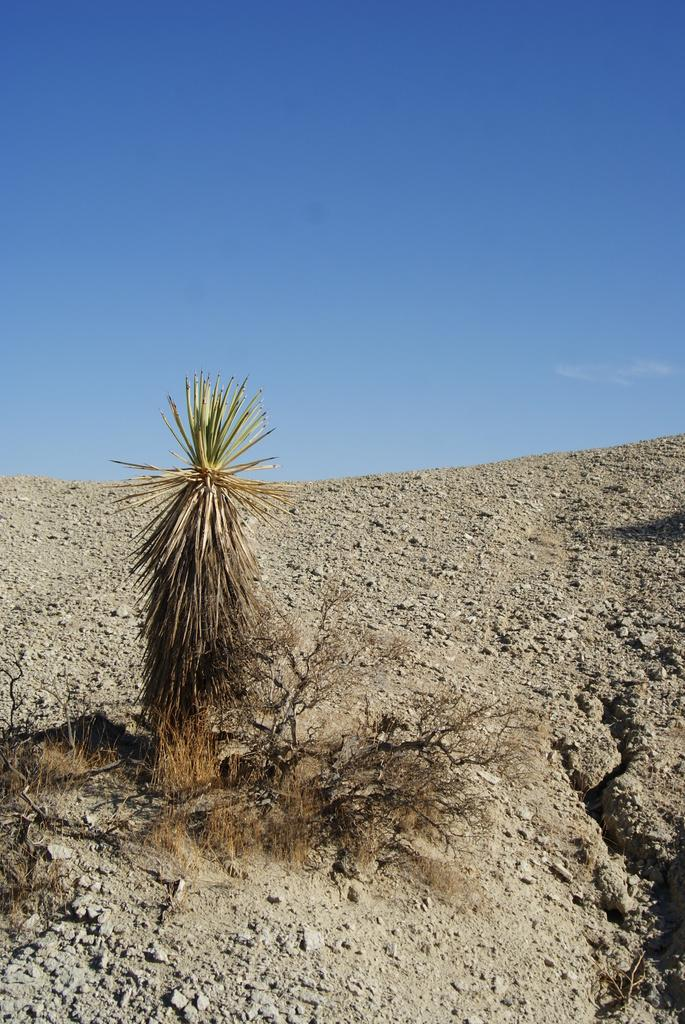What objects are on the ground in the image? There are planets on the ground in the image. What can be seen in the background of the image? The sky is visible in the background of the image. What type of knee injury is the carpenter suffering from in the image? There is no carpenter or knee injury present in the image; it features planets on the ground and a visible sky. What riddle can be solved by looking at the planets in the image? There is no riddle associated with the planets in the image; they are simply depicted on the ground. 